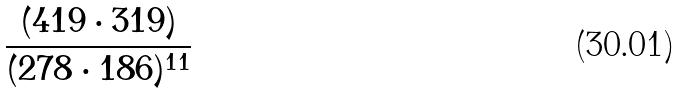<formula> <loc_0><loc_0><loc_500><loc_500>\frac { ( 4 1 9 \cdot 3 1 9 ) } { ( 2 7 8 \cdot 1 8 6 ) ^ { 1 1 } }</formula> 